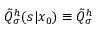<formula> <loc_0><loc_0><loc_500><loc_500>\tilde { Q } _ { \sigma } ^ { h } ( s | x _ { 0 } ) \equiv \tilde { Q } _ { \sigma } ^ { h }</formula> 